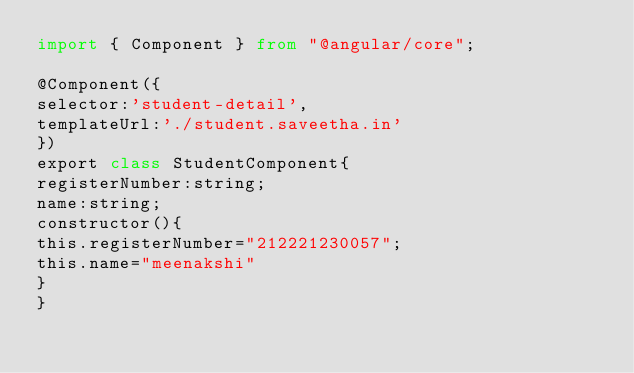Convert code to text. <code><loc_0><loc_0><loc_500><loc_500><_Python_>import { Component } from "@angular/core";

@Component({
selector:'student-detail',
templateUrl:'./student.saveetha.in'
})
export class StudentComponent{
registerNumber:string;
name:string;
constructor(){
this.registerNumber="212221230057";
this.name="meenakshi"
}
}
</code> 